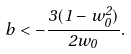Convert formula to latex. <formula><loc_0><loc_0><loc_500><loc_500>b < - \frac { 3 ( 1 - w _ { 0 } ^ { 2 } ) } { 2 w _ { 0 } } .</formula> 